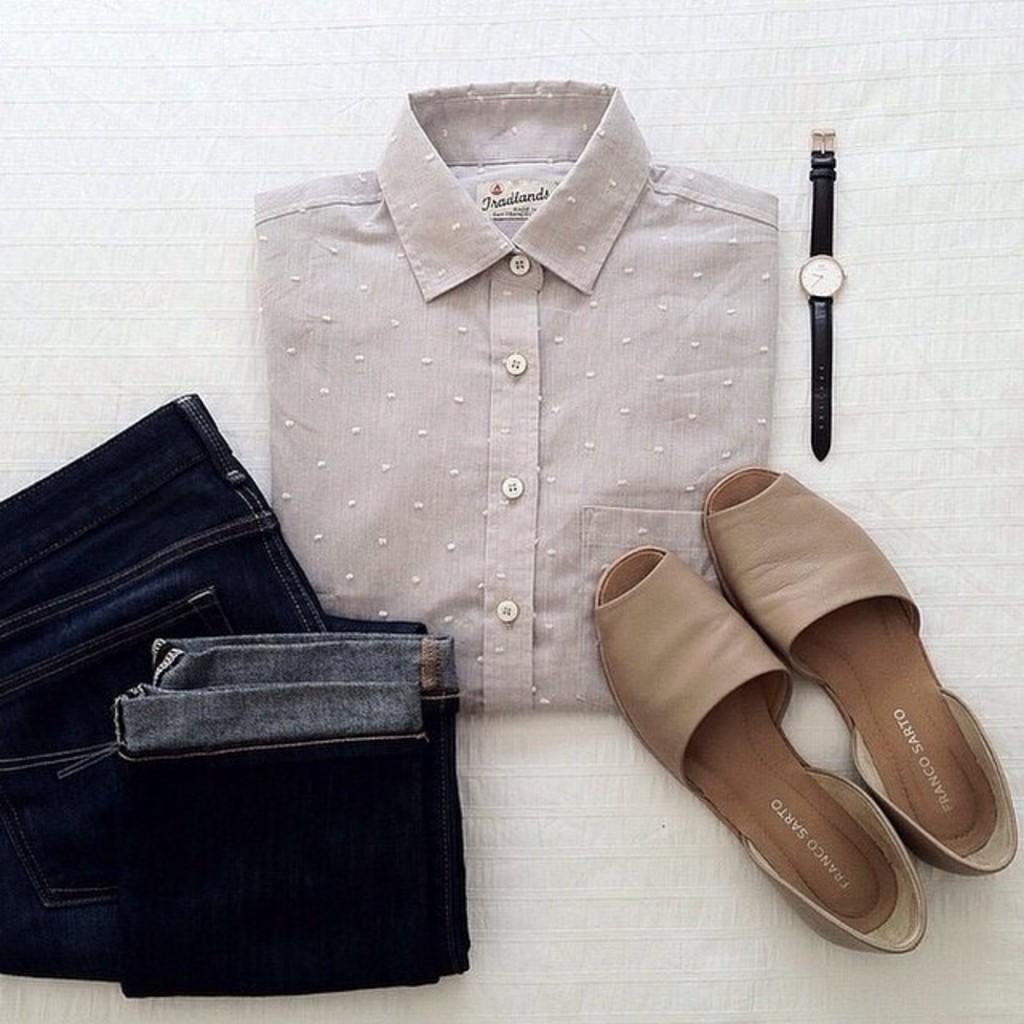Can you describe this image briefly? In this image, we can see a shirt, pant, chappal and a watch. 